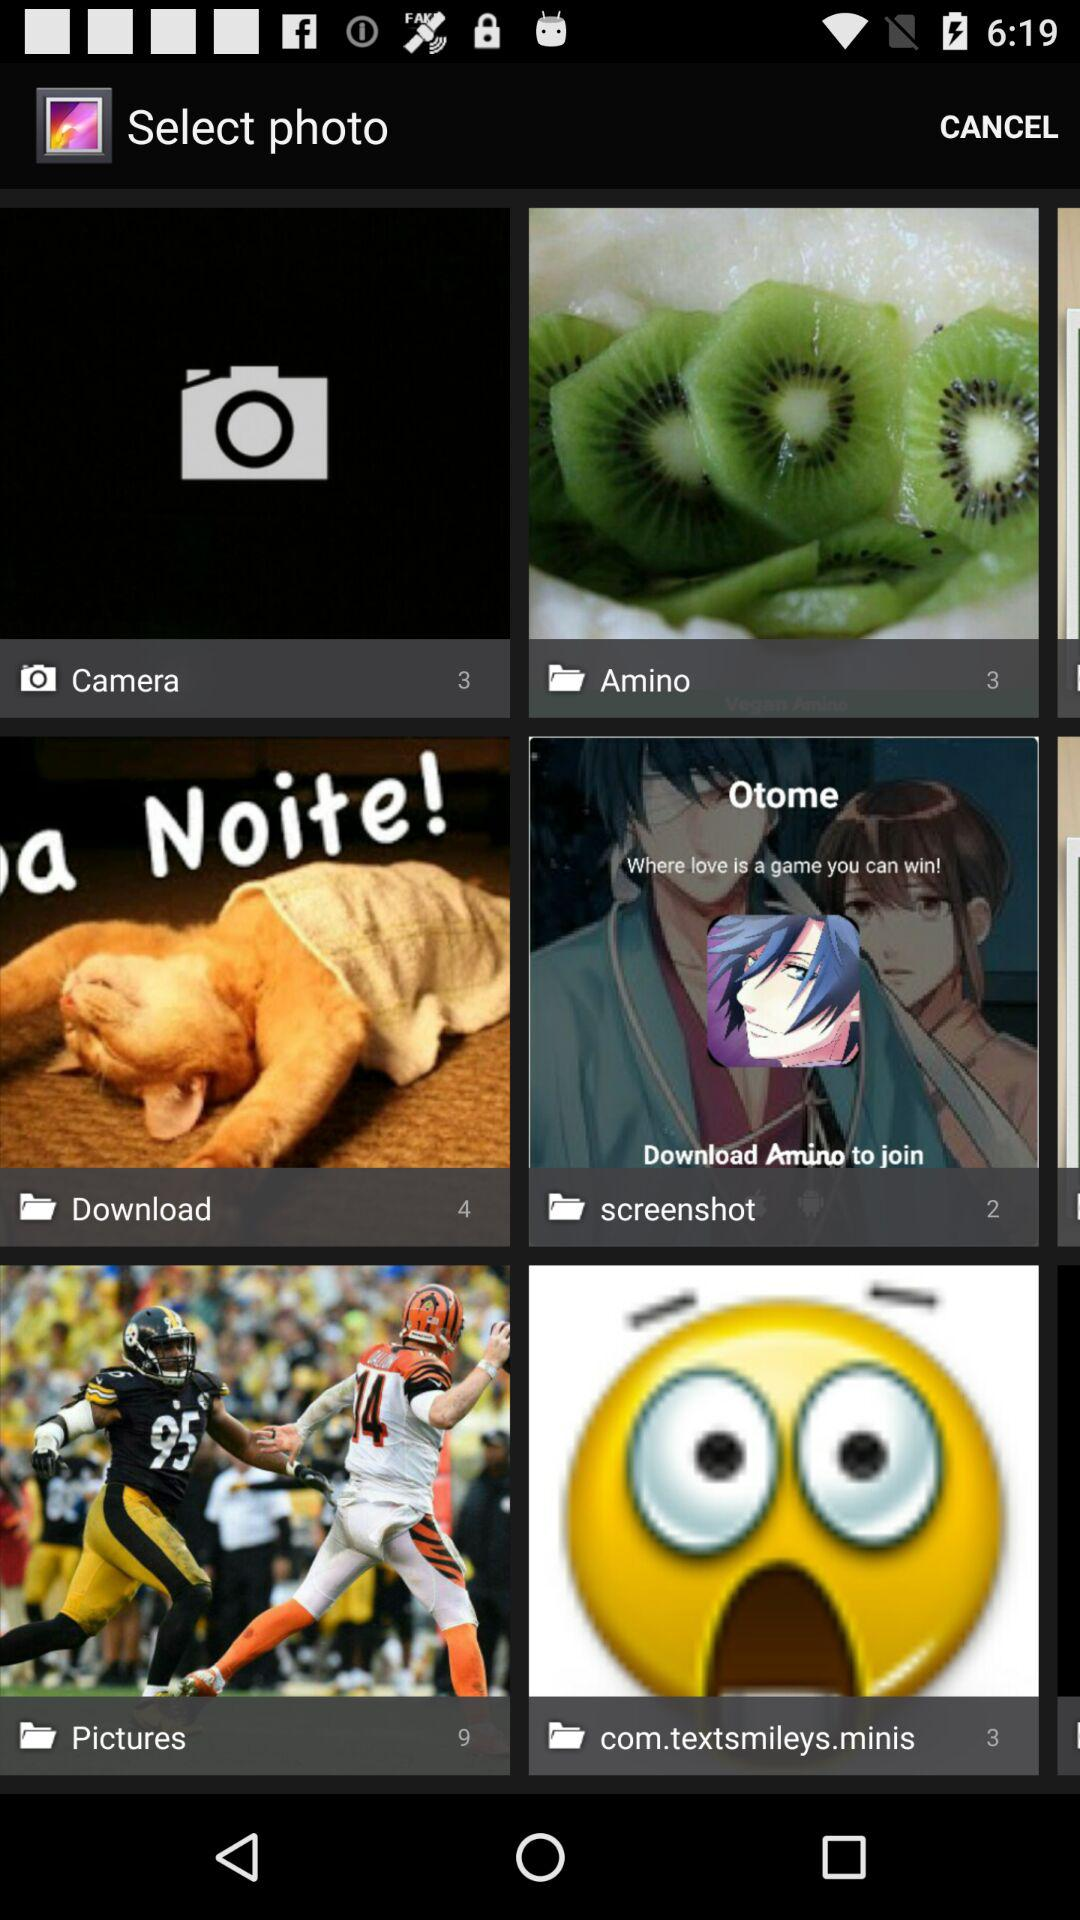What is the count of the images in the "Amino" folder? The count of the images in the "Amino" folder is 3. 